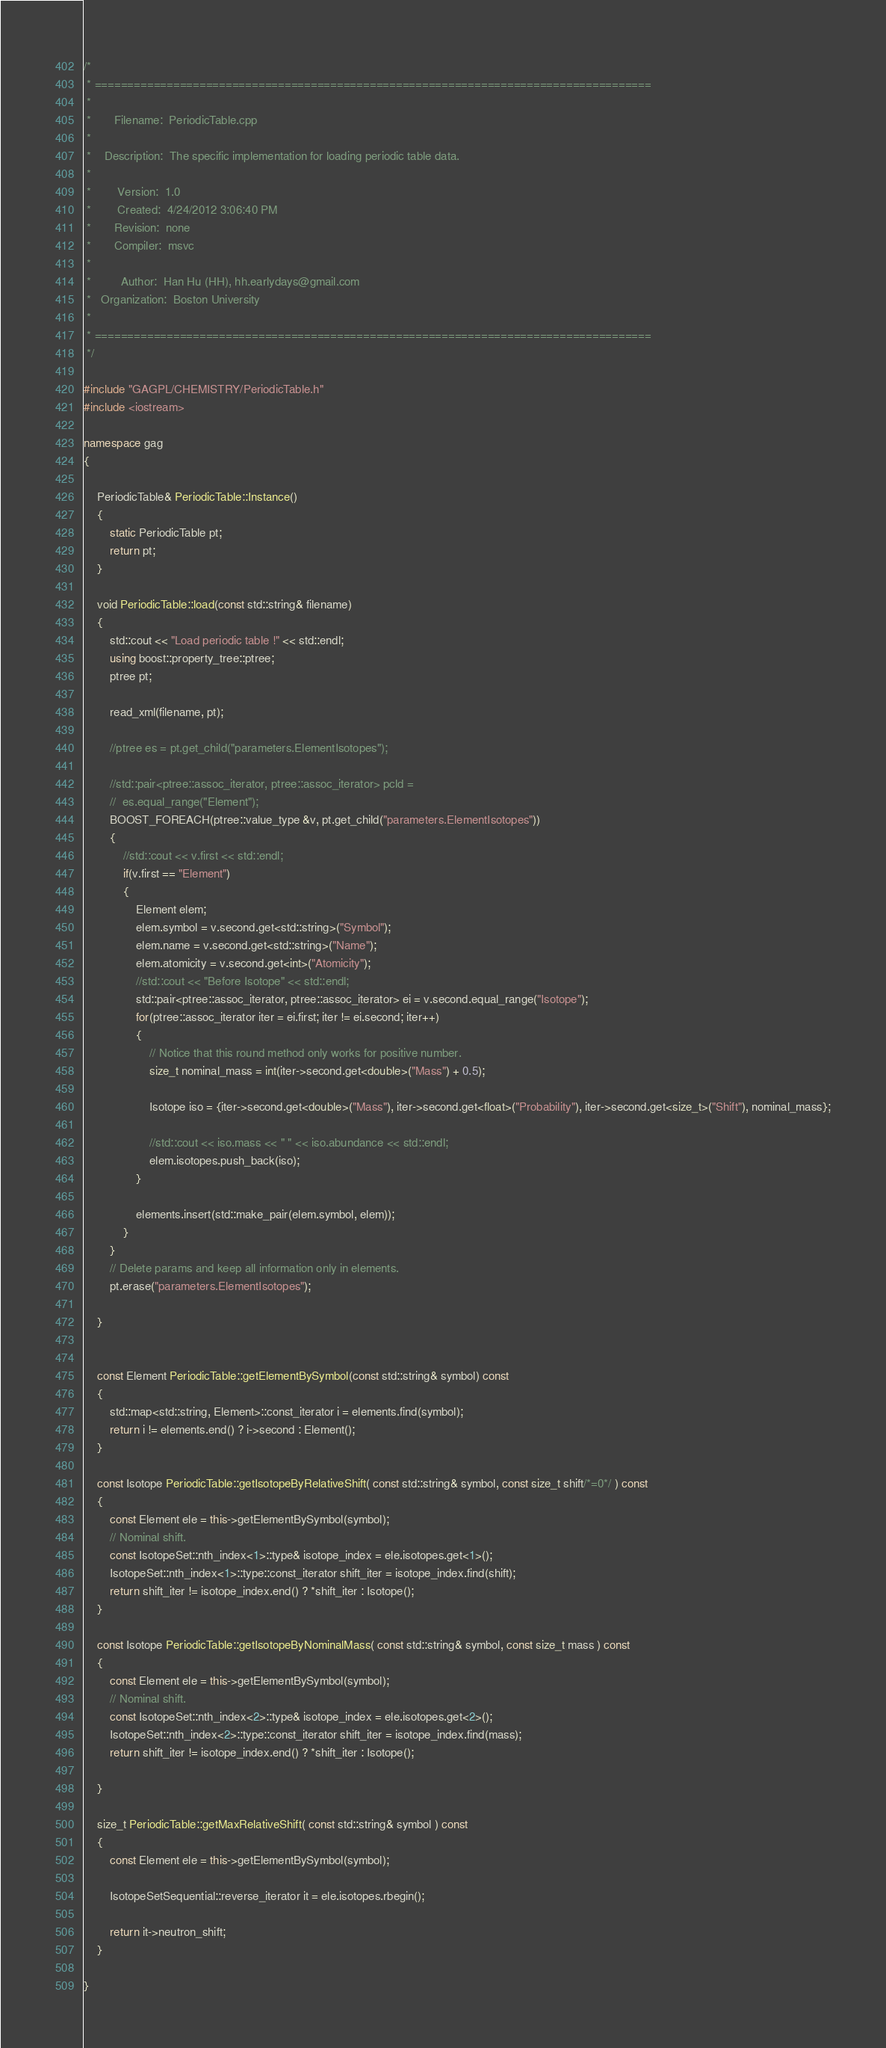<code> <loc_0><loc_0><loc_500><loc_500><_C++_>/*
 * =====================================================================================
 *
 *       Filename:  PeriodicTable.cpp
 *
 *    Description:  The specific implementation for loading periodic table data.  
 *
 *        Version:  1.0
 *        Created:  4/24/2012 3:06:40 PM
 *       Revision:  none
 *       Compiler:  msvc
 *
 *         Author:  Han Hu (HH), hh.earlydays@gmail.com 
 *   Organization:  Boston University
 *
 * =====================================================================================
 */

#include "GAGPL/CHEMISTRY/PeriodicTable.h"
#include <iostream>

namespace gag
{

	PeriodicTable& PeriodicTable::Instance()
	{
		static PeriodicTable pt;
		return pt;
	}

	void PeriodicTable::load(const std::string& filename)
	{
		std::cout << "Load periodic table !" << std::endl;
		using boost::property_tree::ptree;
		ptree pt;
		
		read_xml(filename, pt);

		//ptree es = pt.get_child("parameters.ElementIsotopes");

		//std::pair<ptree::assoc_iterator, ptree::assoc_iterator> pcld = 
		//	es.equal_range("Element");
		BOOST_FOREACH(ptree::value_type &v, pt.get_child("parameters.ElementIsotopes"))
		{
			//std::cout << v.first << std::endl;
			if(v.first == "Element")
			{
				Element elem;
				elem.symbol = v.second.get<std::string>("Symbol");
				elem.name = v.second.get<std::string>("Name");
				elem.atomicity = v.second.get<int>("Atomicity");
				//std::cout << "Before Isotope" << std::endl;
				std::pair<ptree::assoc_iterator, ptree::assoc_iterator> ei = v.second.equal_range("Isotope");
				for(ptree::assoc_iterator iter = ei.first; iter != ei.second; iter++)
				{
					// Notice that this round method only works for positive number.
					size_t nominal_mass = int(iter->second.get<double>("Mass") + 0.5);
					
					Isotope iso = {iter->second.get<double>("Mass"), iter->second.get<float>("Probability"), iter->second.get<size_t>("Shift"), nominal_mass};

					//std::cout << iso.mass << " " << iso.abundance << std::endl;
					elem.isotopes.push_back(iso);					
				}

				elements.insert(std::make_pair(elem.symbol, elem));
			}
		}	
		// Delete params and keep all information only in elements.
		pt.erase("parameters.ElementIsotopes");
	
	}


	const Element PeriodicTable::getElementBySymbol(const std::string& symbol) const
	{
		std::map<std::string, Element>::const_iterator i = elements.find(symbol);
		return i != elements.end() ? i->second : Element();
	}

	const Isotope PeriodicTable::getIsotopeByRelativeShift( const std::string& symbol, const size_t shift/*=0*/ ) const
	{
		const Element ele = this->getElementBySymbol(symbol);
		// Nominal shift.
		const IsotopeSet::nth_index<1>::type& isotope_index = ele.isotopes.get<1>();
		IsotopeSet::nth_index<1>::type::const_iterator shift_iter = isotope_index.find(shift);
		return shift_iter != isotope_index.end() ? *shift_iter : Isotope();
	}

	const Isotope PeriodicTable::getIsotopeByNominalMass( const std::string& symbol, const size_t mass ) const
	{
		const Element ele = this->getElementBySymbol(symbol);
		// Nominal shift.
		const IsotopeSet::nth_index<2>::type& isotope_index = ele.isotopes.get<2>();
		IsotopeSet::nth_index<2>::type::const_iterator shift_iter = isotope_index.find(mass);
		return shift_iter != isotope_index.end() ? *shift_iter : Isotope();

	}

	size_t PeriodicTable::getMaxRelativeShift( const std::string& symbol ) const
	{
		const Element ele = this->getElementBySymbol(symbol);

		IsotopeSetSequential::reverse_iterator it = ele.isotopes.rbegin();

		return it->neutron_shift;
	}

}

</code> 